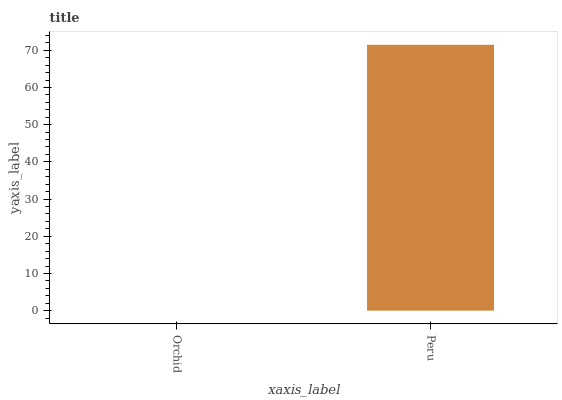Is Orchid the minimum?
Answer yes or no. Yes. Is Peru the maximum?
Answer yes or no. Yes. Is Peru the minimum?
Answer yes or no. No. Is Peru greater than Orchid?
Answer yes or no. Yes. Is Orchid less than Peru?
Answer yes or no. Yes. Is Orchid greater than Peru?
Answer yes or no. No. Is Peru less than Orchid?
Answer yes or no. No. Is Peru the high median?
Answer yes or no. Yes. Is Orchid the low median?
Answer yes or no. Yes. Is Orchid the high median?
Answer yes or no. No. Is Peru the low median?
Answer yes or no. No. 